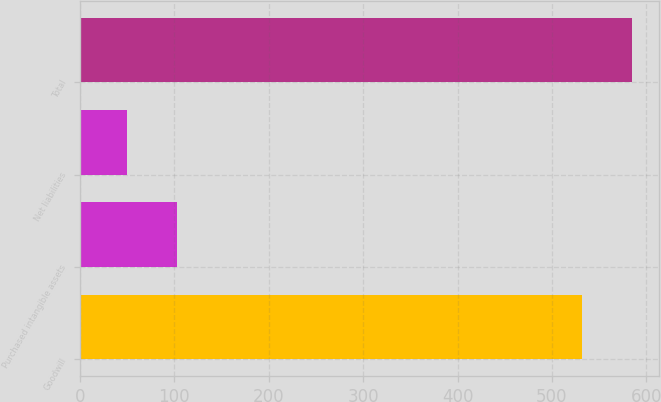Convert chart to OTSL. <chart><loc_0><loc_0><loc_500><loc_500><bar_chart><fcel>Goodwill<fcel>Purchased intangible assets<fcel>Net liabilities<fcel>Total<nl><fcel>532<fcel>102.3<fcel>50<fcel>584.3<nl></chart> 